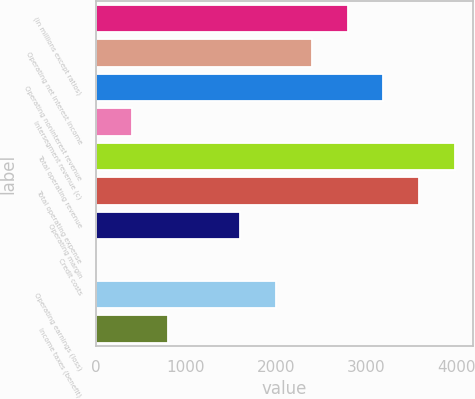Convert chart to OTSL. <chart><loc_0><loc_0><loc_500><loc_500><bar_chart><fcel>(in millions except ratios)<fcel>Operating net interest income<fcel>Operating noninterest revenue<fcel>Intersegment revenue (c)<fcel>Total operating revenue<fcel>Total operating expense<fcel>Operating margin<fcel>Credit costs<fcel>Operating earnings (loss)<fcel>Income taxes (benefit)<nl><fcel>2794.7<fcel>2395.6<fcel>3193.8<fcel>400.1<fcel>3992<fcel>3592.9<fcel>1597.4<fcel>1<fcel>1996.5<fcel>799.2<nl></chart> 